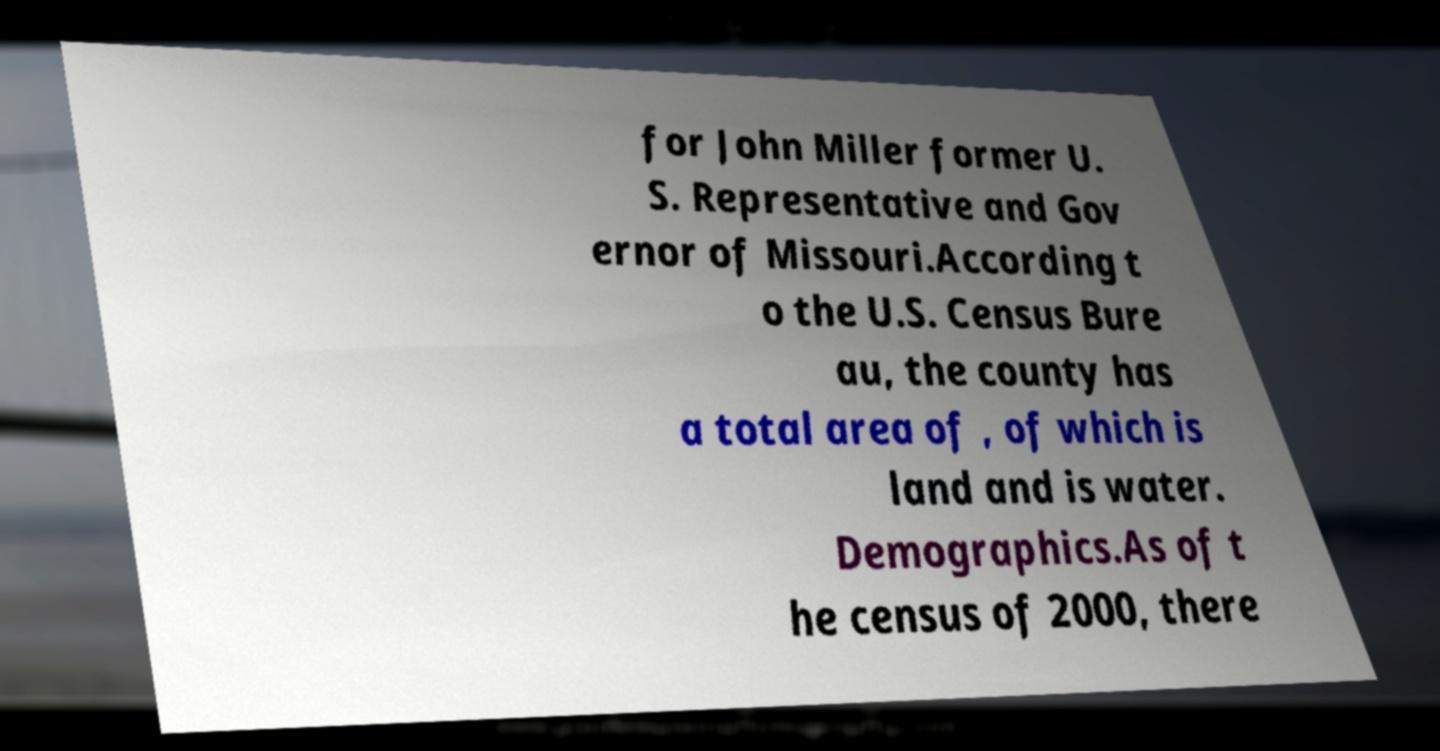Can you accurately transcribe the text from the provided image for me? for John Miller former U. S. Representative and Gov ernor of Missouri.According t o the U.S. Census Bure au, the county has a total area of , of which is land and is water. Demographics.As of t he census of 2000, there 